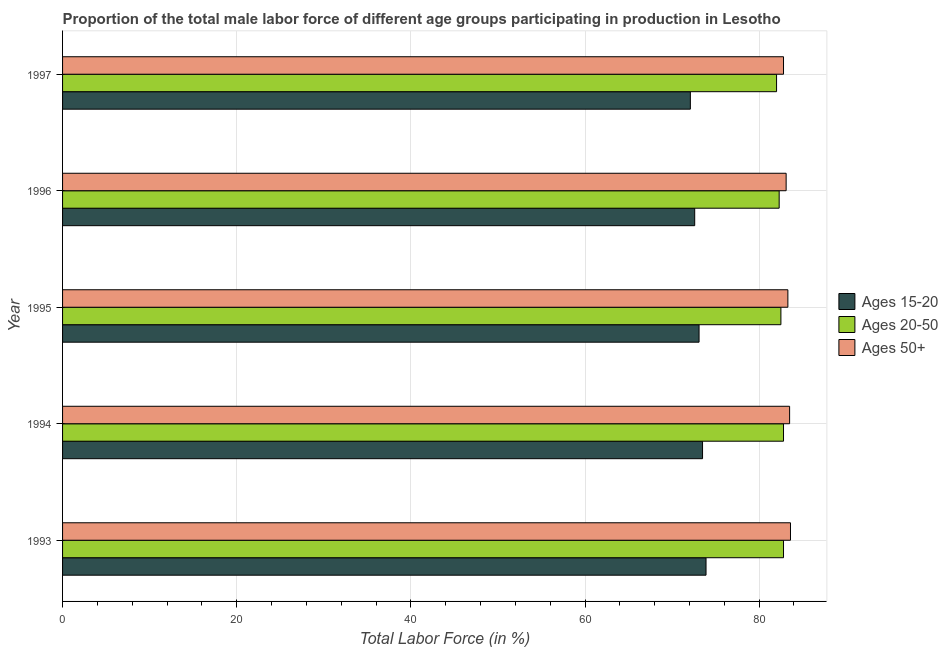How many groups of bars are there?
Your answer should be compact. 5. Are the number of bars per tick equal to the number of legend labels?
Provide a short and direct response. Yes. Are the number of bars on each tick of the Y-axis equal?
Offer a terse response. Yes. How many bars are there on the 1st tick from the top?
Keep it short and to the point. 3. Across all years, what is the maximum percentage of male labor force within the age group 20-50?
Your answer should be very brief. 82.8. Across all years, what is the minimum percentage of male labor force above age 50?
Your response must be concise. 82.8. In which year was the percentage of male labor force above age 50 maximum?
Ensure brevity in your answer.  1993. In which year was the percentage of male labor force within the age group 20-50 minimum?
Offer a terse response. 1997. What is the total percentage of male labor force within the age group 15-20 in the graph?
Your answer should be compact. 365.2. What is the difference between the percentage of male labor force within the age group 15-20 in 1995 and that in 1997?
Offer a terse response. 1. What is the average percentage of male labor force within the age group 15-20 per year?
Make the answer very short. 73.04. In how many years, is the percentage of male labor force above age 50 greater than 80 %?
Your answer should be very brief. 5. What is the difference between the highest and the second highest percentage of male labor force above age 50?
Your response must be concise. 0.1. In how many years, is the percentage of male labor force within the age group 20-50 greater than the average percentage of male labor force within the age group 20-50 taken over all years?
Keep it short and to the point. 3. What does the 2nd bar from the top in 1993 represents?
Provide a short and direct response. Ages 20-50. What does the 1st bar from the bottom in 1993 represents?
Provide a short and direct response. Ages 15-20. Is it the case that in every year, the sum of the percentage of male labor force within the age group 15-20 and percentage of male labor force within the age group 20-50 is greater than the percentage of male labor force above age 50?
Give a very brief answer. Yes. How many bars are there?
Provide a succinct answer. 15. How many years are there in the graph?
Provide a short and direct response. 5. Are the values on the major ticks of X-axis written in scientific E-notation?
Provide a succinct answer. No. Where does the legend appear in the graph?
Make the answer very short. Center right. What is the title of the graph?
Keep it short and to the point. Proportion of the total male labor force of different age groups participating in production in Lesotho. Does "Transport equipments" appear as one of the legend labels in the graph?
Your response must be concise. No. What is the label or title of the Y-axis?
Your response must be concise. Year. What is the Total Labor Force (in %) in Ages 15-20 in 1993?
Ensure brevity in your answer.  73.9. What is the Total Labor Force (in %) in Ages 20-50 in 1993?
Keep it short and to the point. 82.8. What is the Total Labor Force (in %) of Ages 50+ in 1993?
Ensure brevity in your answer.  83.6. What is the Total Labor Force (in %) of Ages 15-20 in 1994?
Offer a very short reply. 73.5. What is the Total Labor Force (in %) in Ages 20-50 in 1994?
Your answer should be compact. 82.8. What is the Total Labor Force (in %) of Ages 50+ in 1994?
Offer a terse response. 83.5. What is the Total Labor Force (in %) in Ages 15-20 in 1995?
Your answer should be very brief. 73.1. What is the Total Labor Force (in %) in Ages 20-50 in 1995?
Give a very brief answer. 82.5. What is the Total Labor Force (in %) of Ages 50+ in 1995?
Ensure brevity in your answer.  83.3. What is the Total Labor Force (in %) in Ages 15-20 in 1996?
Your response must be concise. 72.6. What is the Total Labor Force (in %) in Ages 20-50 in 1996?
Provide a succinct answer. 82.3. What is the Total Labor Force (in %) of Ages 50+ in 1996?
Provide a short and direct response. 83.1. What is the Total Labor Force (in %) of Ages 15-20 in 1997?
Your answer should be compact. 72.1. What is the Total Labor Force (in %) of Ages 50+ in 1997?
Your answer should be very brief. 82.8. Across all years, what is the maximum Total Labor Force (in %) of Ages 15-20?
Make the answer very short. 73.9. Across all years, what is the maximum Total Labor Force (in %) of Ages 20-50?
Keep it short and to the point. 82.8. Across all years, what is the maximum Total Labor Force (in %) in Ages 50+?
Provide a succinct answer. 83.6. Across all years, what is the minimum Total Labor Force (in %) of Ages 15-20?
Provide a succinct answer. 72.1. Across all years, what is the minimum Total Labor Force (in %) of Ages 50+?
Give a very brief answer. 82.8. What is the total Total Labor Force (in %) of Ages 15-20 in the graph?
Offer a very short reply. 365.2. What is the total Total Labor Force (in %) in Ages 20-50 in the graph?
Your answer should be compact. 412.4. What is the total Total Labor Force (in %) in Ages 50+ in the graph?
Ensure brevity in your answer.  416.3. What is the difference between the Total Labor Force (in %) in Ages 15-20 in 1993 and that in 1994?
Give a very brief answer. 0.4. What is the difference between the Total Labor Force (in %) of Ages 50+ in 1993 and that in 1994?
Provide a succinct answer. 0.1. What is the difference between the Total Labor Force (in %) in Ages 20-50 in 1993 and that in 1995?
Give a very brief answer. 0.3. What is the difference between the Total Labor Force (in %) in Ages 50+ in 1993 and that in 1995?
Your answer should be very brief. 0.3. What is the difference between the Total Labor Force (in %) in Ages 20-50 in 1993 and that in 1996?
Your response must be concise. 0.5. What is the difference between the Total Labor Force (in %) of Ages 15-20 in 1994 and that in 1995?
Make the answer very short. 0.4. What is the difference between the Total Labor Force (in %) of Ages 20-50 in 1994 and that in 1995?
Make the answer very short. 0.3. What is the difference between the Total Labor Force (in %) of Ages 15-20 in 1994 and that in 1996?
Your response must be concise. 0.9. What is the difference between the Total Labor Force (in %) in Ages 20-50 in 1994 and that in 1996?
Keep it short and to the point. 0.5. What is the difference between the Total Labor Force (in %) of Ages 50+ in 1994 and that in 1996?
Make the answer very short. 0.4. What is the difference between the Total Labor Force (in %) in Ages 20-50 in 1994 and that in 1997?
Ensure brevity in your answer.  0.8. What is the difference between the Total Labor Force (in %) of Ages 15-20 in 1995 and that in 1996?
Provide a succinct answer. 0.5. What is the difference between the Total Labor Force (in %) in Ages 20-50 in 1995 and that in 1996?
Provide a short and direct response. 0.2. What is the difference between the Total Labor Force (in %) of Ages 50+ in 1995 and that in 1996?
Your answer should be very brief. 0.2. What is the difference between the Total Labor Force (in %) of Ages 20-50 in 1995 and that in 1997?
Offer a very short reply. 0.5. What is the difference between the Total Labor Force (in %) in Ages 15-20 in 1996 and that in 1997?
Provide a succinct answer. 0.5. What is the difference between the Total Labor Force (in %) of Ages 50+ in 1996 and that in 1997?
Give a very brief answer. 0.3. What is the difference between the Total Labor Force (in %) of Ages 15-20 in 1993 and the Total Labor Force (in %) of Ages 20-50 in 1994?
Offer a very short reply. -8.9. What is the difference between the Total Labor Force (in %) of Ages 20-50 in 1993 and the Total Labor Force (in %) of Ages 50+ in 1994?
Make the answer very short. -0.7. What is the difference between the Total Labor Force (in %) of Ages 20-50 in 1993 and the Total Labor Force (in %) of Ages 50+ in 1995?
Offer a terse response. -0.5. What is the difference between the Total Labor Force (in %) of Ages 15-20 in 1993 and the Total Labor Force (in %) of Ages 20-50 in 1996?
Ensure brevity in your answer.  -8.4. What is the difference between the Total Labor Force (in %) of Ages 15-20 in 1993 and the Total Labor Force (in %) of Ages 50+ in 1997?
Make the answer very short. -8.9. What is the difference between the Total Labor Force (in %) in Ages 20-50 in 1993 and the Total Labor Force (in %) in Ages 50+ in 1997?
Your response must be concise. 0. What is the difference between the Total Labor Force (in %) of Ages 20-50 in 1994 and the Total Labor Force (in %) of Ages 50+ in 1995?
Your response must be concise. -0.5. What is the difference between the Total Labor Force (in %) of Ages 15-20 in 1994 and the Total Labor Force (in %) of Ages 20-50 in 1996?
Ensure brevity in your answer.  -8.8. What is the difference between the Total Labor Force (in %) in Ages 20-50 in 1994 and the Total Labor Force (in %) in Ages 50+ in 1996?
Your answer should be compact. -0.3. What is the difference between the Total Labor Force (in %) of Ages 15-20 in 1994 and the Total Labor Force (in %) of Ages 20-50 in 1997?
Ensure brevity in your answer.  -8.5. What is the difference between the Total Labor Force (in %) of Ages 15-20 in 1994 and the Total Labor Force (in %) of Ages 50+ in 1997?
Provide a succinct answer. -9.3. What is the difference between the Total Labor Force (in %) in Ages 20-50 in 1994 and the Total Labor Force (in %) in Ages 50+ in 1997?
Provide a succinct answer. 0. What is the difference between the Total Labor Force (in %) in Ages 20-50 in 1995 and the Total Labor Force (in %) in Ages 50+ in 1996?
Provide a succinct answer. -0.6. What is the difference between the Total Labor Force (in %) of Ages 15-20 in 1995 and the Total Labor Force (in %) of Ages 20-50 in 1997?
Ensure brevity in your answer.  -8.9. What is the difference between the Total Labor Force (in %) in Ages 20-50 in 1996 and the Total Labor Force (in %) in Ages 50+ in 1997?
Give a very brief answer. -0.5. What is the average Total Labor Force (in %) of Ages 15-20 per year?
Ensure brevity in your answer.  73.04. What is the average Total Labor Force (in %) in Ages 20-50 per year?
Offer a terse response. 82.48. What is the average Total Labor Force (in %) of Ages 50+ per year?
Your answer should be compact. 83.26. In the year 1993, what is the difference between the Total Labor Force (in %) in Ages 20-50 and Total Labor Force (in %) in Ages 50+?
Give a very brief answer. -0.8. In the year 1994, what is the difference between the Total Labor Force (in %) in Ages 15-20 and Total Labor Force (in %) in Ages 20-50?
Your answer should be compact. -9.3. In the year 1994, what is the difference between the Total Labor Force (in %) of Ages 15-20 and Total Labor Force (in %) of Ages 50+?
Give a very brief answer. -10. In the year 1994, what is the difference between the Total Labor Force (in %) in Ages 20-50 and Total Labor Force (in %) in Ages 50+?
Your answer should be compact. -0.7. In the year 1996, what is the difference between the Total Labor Force (in %) of Ages 15-20 and Total Labor Force (in %) of Ages 50+?
Your answer should be compact. -10.5. In the year 1996, what is the difference between the Total Labor Force (in %) in Ages 20-50 and Total Labor Force (in %) in Ages 50+?
Offer a terse response. -0.8. In the year 1997, what is the difference between the Total Labor Force (in %) of Ages 15-20 and Total Labor Force (in %) of Ages 50+?
Offer a terse response. -10.7. In the year 1997, what is the difference between the Total Labor Force (in %) in Ages 20-50 and Total Labor Force (in %) in Ages 50+?
Keep it short and to the point. -0.8. What is the ratio of the Total Labor Force (in %) in Ages 15-20 in 1993 to that in 1994?
Provide a succinct answer. 1.01. What is the ratio of the Total Labor Force (in %) in Ages 50+ in 1993 to that in 1994?
Ensure brevity in your answer.  1. What is the ratio of the Total Labor Force (in %) of Ages 15-20 in 1993 to that in 1995?
Make the answer very short. 1.01. What is the ratio of the Total Labor Force (in %) in Ages 20-50 in 1993 to that in 1995?
Your answer should be very brief. 1. What is the ratio of the Total Labor Force (in %) in Ages 50+ in 1993 to that in 1995?
Give a very brief answer. 1. What is the ratio of the Total Labor Force (in %) of Ages 15-20 in 1993 to that in 1996?
Give a very brief answer. 1.02. What is the ratio of the Total Labor Force (in %) in Ages 50+ in 1993 to that in 1996?
Give a very brief answer. 1.01. What is the ratio of the Total Labor Force (in %) of Ages 20-50 in 1993 to that in 1997?
Offer a terse response. 1.01. What is the ratio of the Total Labor Force (in %) in Ages 50+ in 1993 to that in 1997?
Keep it short and to the point. 1.01. What is the ratio of the Total Labor Force (in %) in Ages 50+ in 1994 to that in 1995?
Offer a terse response. 1. What is the ratio of the Total Labor Force (in %) in Ages 15-20 in 1994 to that in 1996?
Ensure brevity in your answer.  1.01. What is the ratio of the Total Labor Force (in %) in Ages 20-50 in 1994 to that in 1996?
Keep it short and to the point. 1.01. What is the ratio of the Total Labor Force (in %) in Ages 50+ in 1994 to that in 1996?
Provide a short and direct response. 1. What is the ratio of the Total Labor Force (in %) in Ages 15-20 in 1994 to that in 1997?
Your answer should be very brief. 1.02. What is the ratio of the Total Labor Force (in %) in Ages 20-50 in 1994 to that in 1997?
Provide a succinct answer. 1.01. What is the ratio of the Total Labor Force (in %) in Ages 50+ in 1994 to that in 1997?
Your response must be concise. 1.01. What is the ratio of the Total Labor Force (in %) in Ages 15-20 in 1995 to that in 1996?
Keep it short and to the point. 1.01. What is the ratio of the Total Labor Force (in %) of Ages 20-50 in 1995 to that in 1996?
Provide a short and direct response. 1. What is the ratio of the Total Labor Force (in %) of Ages 50+ in 1995 to that in 1996?
Offer a very short reply. 1. What is the ratio of the Total Labor Force (in %) of Ages 15-20 in 1995 to that in 1997?
Provide a succinct answer. 1.01. What is the ratio of the Total Labor Force (in %) in Ages 20-50 in 1995 to that in 1997?
Provide a short and direct response. 1.01. What is the ratio of the Total Labor Force (in %) in Ages 50+ in 1995 to that in 1997?
Your answer should be compact. 1.01. What is the ratio of the Total Labor Force (in %) in Ages 20-50 in 1996 to that in 1997?
Keep it short and to the point. 1. What is the ratio of the Total Labor Force (in %) of Ages 50+ in 1996 to that in 1997?
Offer a very short reply. 1. What is the difference between the highest and the second highest Total Labor Force (in %) in Ages 20-50?
Keep it short and to the point. 0. What is the difference between the highest and the second highest Total Labor Force (in %) in Ages 50+?
Your response must be concise. 0.1. 